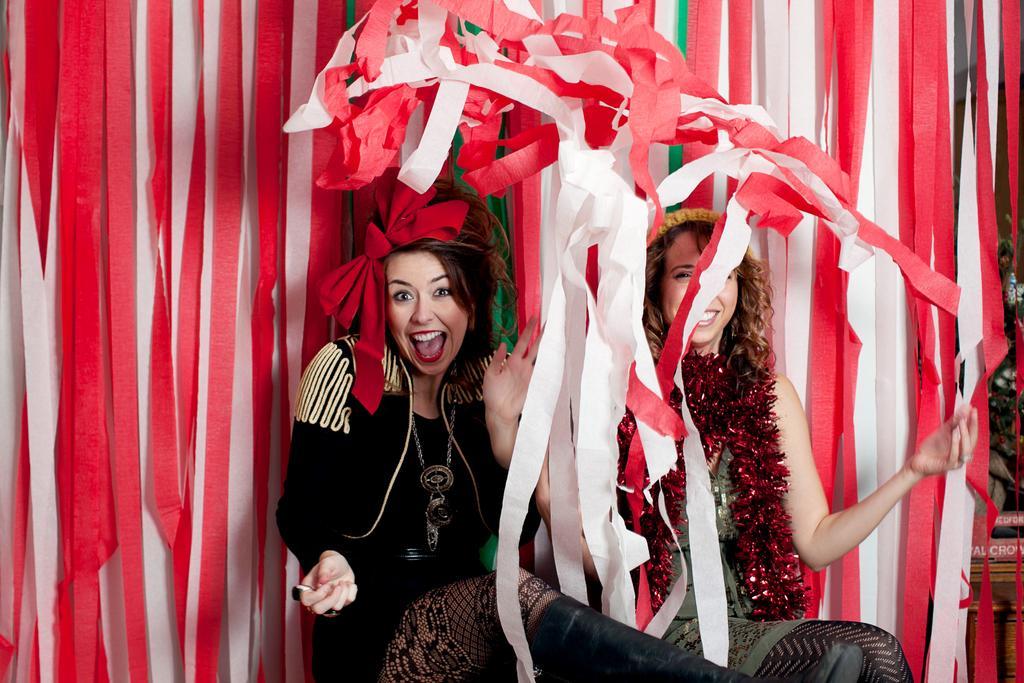In one or two sentences, can you explain what this image depicts? In the picture we can see two women are sitting with different costumes and they are laughing and behind them, we can see a wall which is decorated with red and white ribbons. 